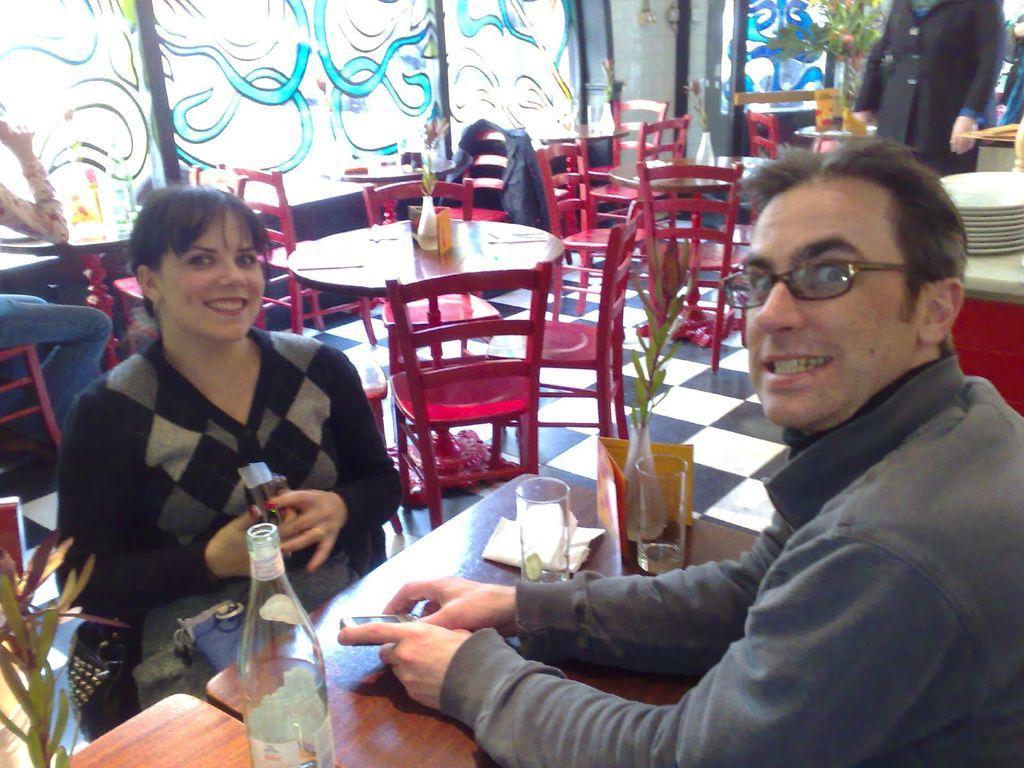Please provide a concise description of this image. This is the picture of two people who are posing for a picture who are sitting in front of a table and on the table we have small plant, glasses, tissues around them there are some tables and chairs on which there are some plants and tissues. 